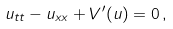<formula> <loc_0><loc_0><loc_500><loc_500>u _ { t t } - u _ { x x } + V ^ { \prime } ( u ) = 0 \, ,</formula> 